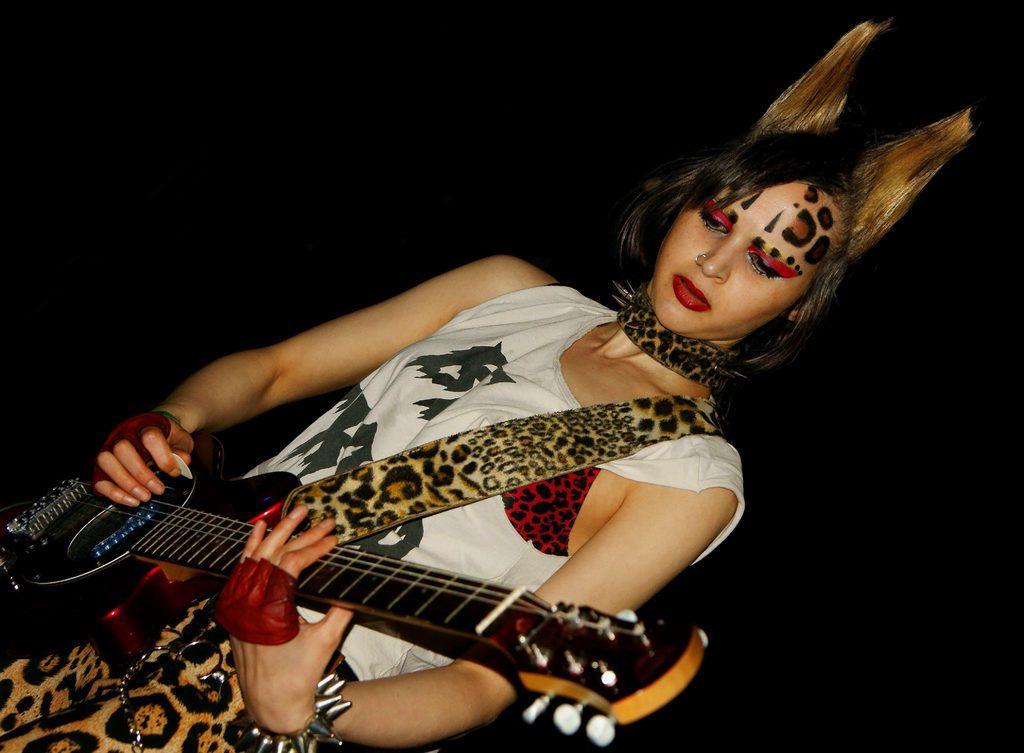Please provide a concise description of this image. As we can see in the image there is a woman holding guitar. 